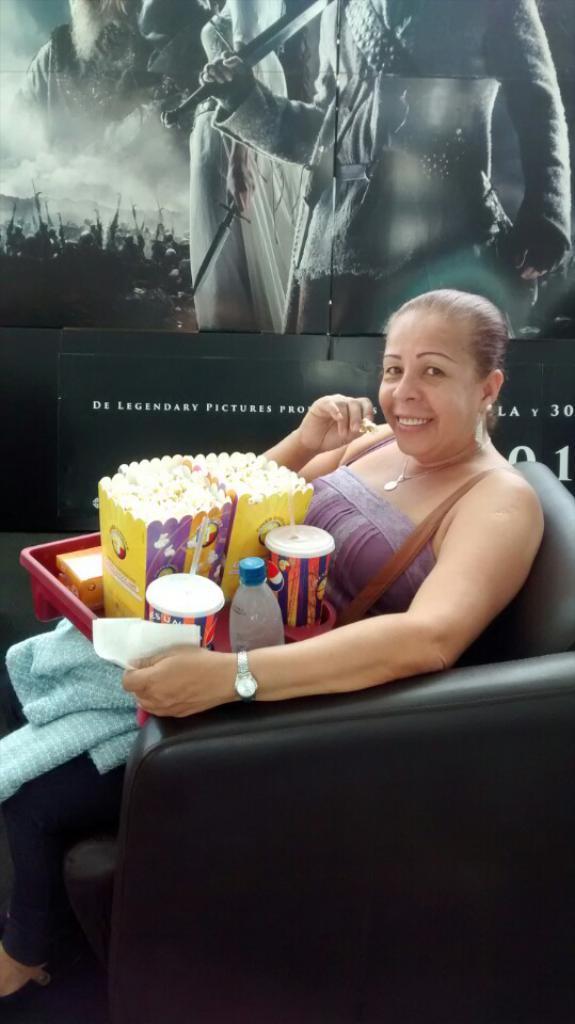Can you describe this image briefly? In this image we can see a lady sitting on the couch, there are some food items on the tray, there is a poster with some images and texts on it. 